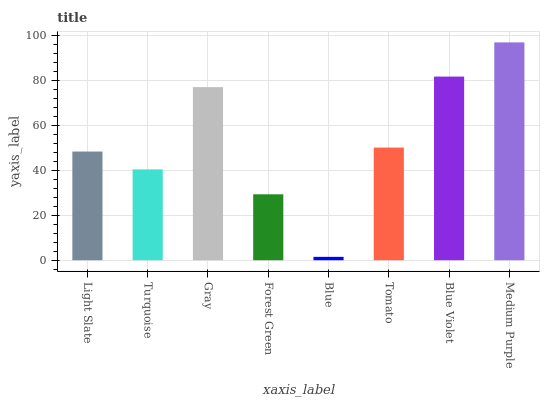Is Blue the minimum?
Answer yes or no. Yes. Is Medium Purple the maximum?
Answer yes or no. Yes. Is Turquoise the minimum?
Answer yes or no. No. Is Turquoise the maximum?
Answer yes or no. No. Is Light Slate greater than Turquoise?
Answer yes or no. Yes. Is Turquoise less than Light Slate?
Answer yes or no. Yes. Is Turquoise greater than Light Slate?
Answer yes or no. No. Is Light Slate less than Turquoise?
Answer yes or no. No. Is Tomato the high median?
Answer yes or no. Yes. Is Light Slate the low median?
Answer yes or no. Yes. Is Blue Violet the high median?
Answer yes or no. No. Is Tomato the low median?
Answer yes or no. No. 